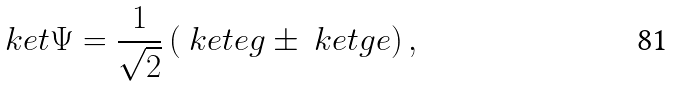<formula> <loc_0><loc_0><loc_500><loc_500>\ k e t { \Psi } = \frac { 1 } { \sqrt { 2 } } \left ( \ k e t { e g } \pm \ k e t { g e } \right ) ,</formula> 